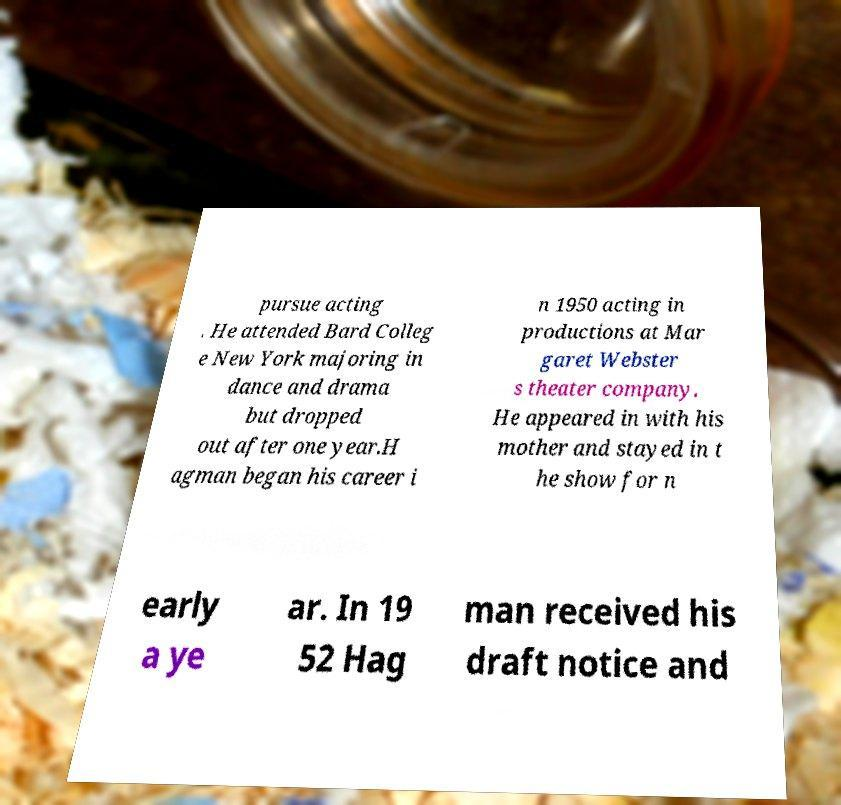Can you read and provide the text displayed in the image?This photo seems to have some interesting text. Can you extract and type it out for me? pursue acting . He attended Bard Colleg e New York majoring in dance and drama but dropped out after one year.H agman began his career i n 1950 acting in productions at Mar garet Webster s theater company. He appeared in with his mother and stayed in t he show for n early a ye ar. In 19 52 Hag man received his draft notice and 